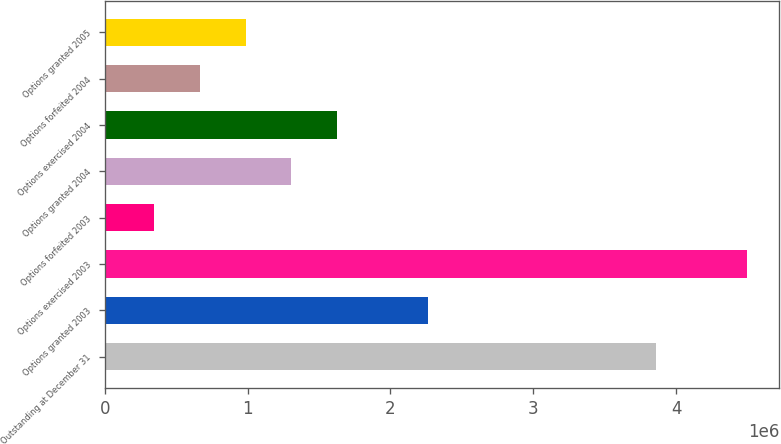<chart> <loc_0><loc_0><loc_500><loc_500><bar_chart><fcel>Outstanding at December 31<fcel>Options granted 2003<fcel>Options exercised 2003<fcel>Options forfeited 2003<fcel>Options granted 2004<fcel>Options exercised 2004<fcel>Options forfeited 2004<fcel>Options granted 2005<nl><fcel>3.85939e+06<fcel>2.26277e+06<fcel>4.49804e+06<fcel>346822<fcel>1.3048e+06<fcel>1.62412e+06<fcel>666146<fcel>985470<nl></chart> 